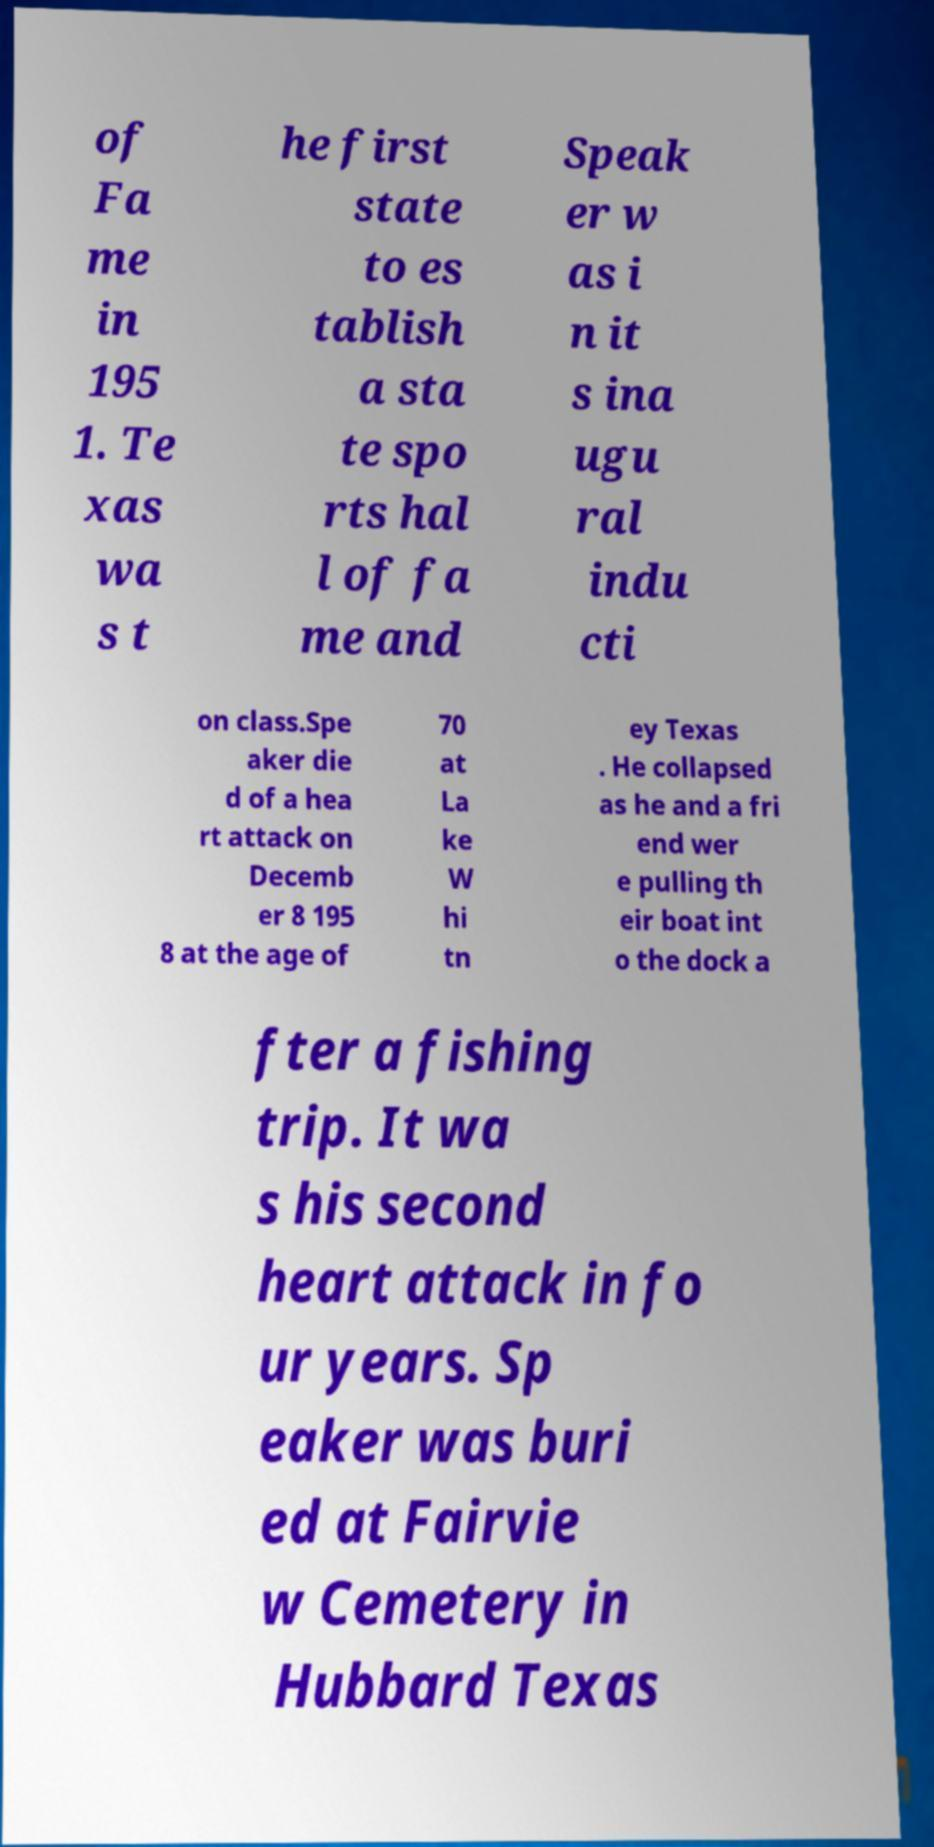For documentation purposes, I need the text within this image transcribed. Could you provide that? of Fa me in 195 1. Te xas wa s t he first state to es tablish a sta te spo rts hal l of fa me and Speak er w as i n it s ina ugu ral indu cti on class.Spe aker die d of a hea rt attack on Decemb er 8 195 8 at the age of 70 at La ke W hi tn ey Texas . He collapsed as he and a fri end wer e pulling th eir boat int o the dock a fter a fishing trip. It wa s his second heart attack in fo ur years. Sp eaker was buri ed at Fairvie w Cemetery in Hubbard Texas 